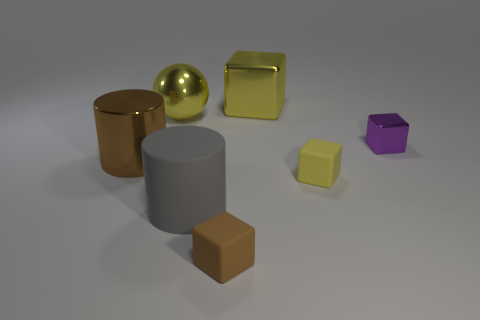What size is the shiny thing that is the same color as the big metallic cube?
Your response must be concise. Large. Is the material of the cube on the right side of the small yellow matte object the same as the large cylinder behind the large gray matte thing?
Give a very brief answer. Yes. What is the material of the small thing that is the same color as the metallic cylinder?
Offer a terse response. Rubber. How many big brown things have the same shape as the yellow matte thing?
Give a very brief answer. 0. Are there more large gray things in front of the gray cylinder than yellow cubes?
Keep it short and to the point. No. There is a big brown object that is in front of the large yellow shiny thing that is to the right of the object that is in front of the gray rubber thing; what is its shape?
Give a very brief answer. Cylinder. Is the shape of the metallic object on the right side of the yellow metallic cube the same as the small brown matte object that is in front of the tiny purple cube?
Your answer should be very brief. Yes. Is there any other thing that has the same size as the purple cube?
Provide a short and direct response. Yes. How many cylinders are either large brown metal things or yellow metal objects?
Give a very brief answer. 1. Are the yellow sphere and the large yellow cube made of the same material?
Offer a terse response. Yes. 